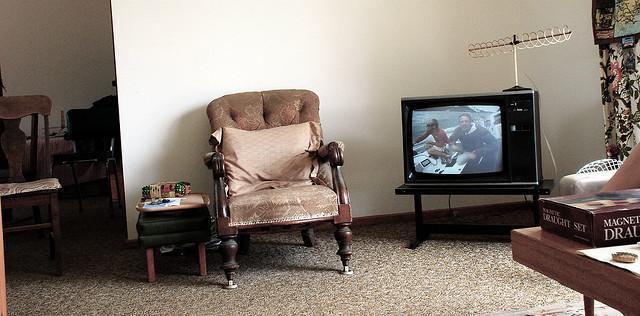How many chairs can be seen?
Give a very brief answer. 2. How many apple brand laptops can you see?
Give a very brief answer. 0. 